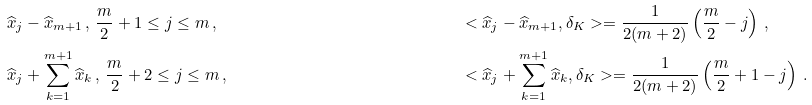Convert formula to latex. <formula><loc_0><loc_0><loc_500><loc_500>\widehat { x } _ { j } & - \widehat { x } _ { m + 1 } \, , \, \frac { m } { 2 } + 1 \leq j \leq m \, , & & & & < \widehat { x } _ { j } - \widehat { x } _ { m + 1 } , \delta _ { K } > = \frac { 1 } { 2 ( m + 2 ) } \left ( \frac { m } { 2 } - j \right ) \, , \\ \widehat { x } _ { j } & + \sum _ { k = 1 } ^ { m + 1 } \widehat { x } _ { k } \, , \, \frac { m } { 2 } + 2 \leq j \leq m \, , & & & & < \widehat { x } _ { j } + \sum _ { k = 1 } ^ { m + 1 } \widehat { x } _ { k } , \delta _ { K } > = \frac { 1 } { 2 ( m + 2 ) } \left ( \frac { m } { 2 } + 1 - j \right ) \, .</formula> 